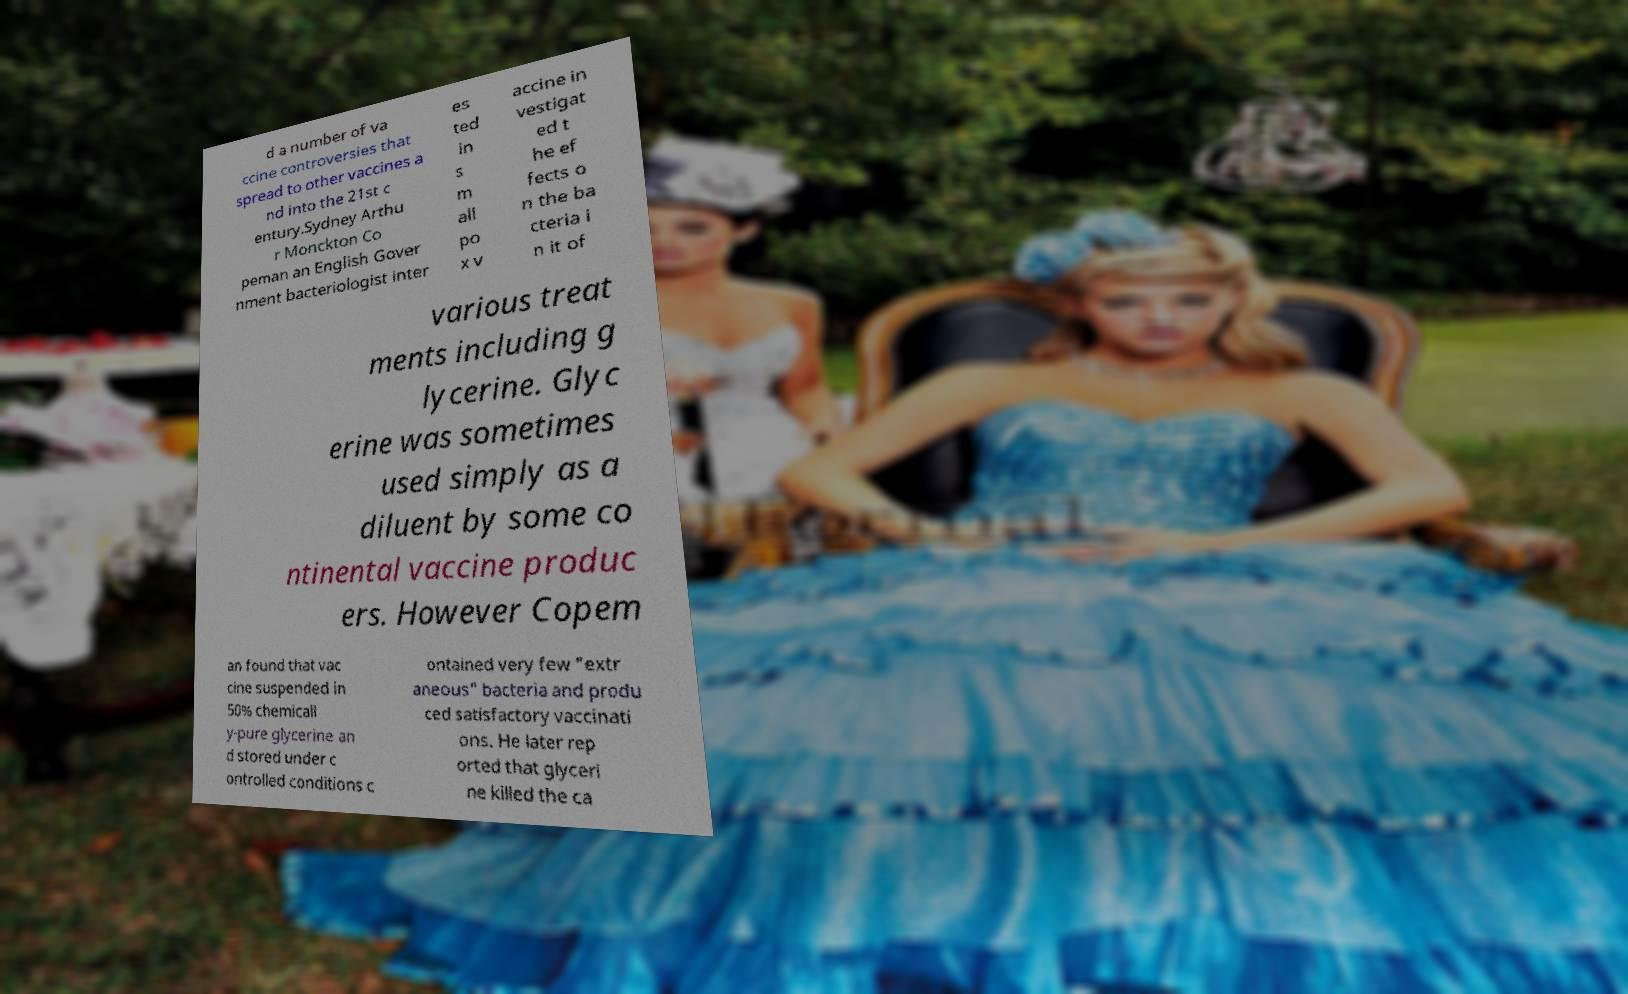For documentation purposes, I need the text within this image transcribed. Could you provide that? d a number of va ccine controversies that spread to other vaccines a nd into the 21st c entury.Sydney Arthu r Monckton Co peman an English Gover nment bacteriologist inter es ted in s m all po x v accine in vestigat ed t he ef fects o n the ba cteria i n it of various treat ments including g lycerine. Glyc erine was sometimes used simply as a diluent by some co ntinental vaccine produc ers. However Copem an found that vac cine suspended in 50% chemicall y-pure glycerine an d stored under c ontrolled conditions c ontained very few "extr aneous" bacteria and produ ced satisfactory vaccinati ons. He later rep orted that glyceri ne killed the ca 